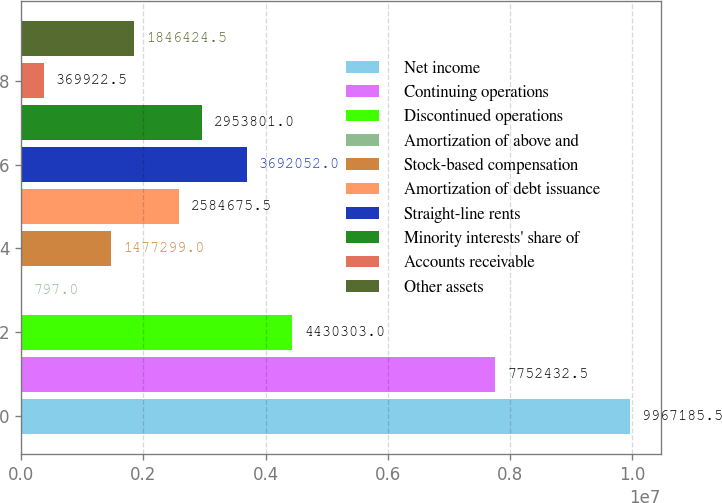Convert chart to OTSL. <chart><loc_0><loc_0><loc_500><loc_500><bar_chart><fcel>Net income<fcel>Continuing operations<fcel>Discontinued operations<fcel>Amortization of above and<fcel>Stock-based compensation<fcel>Amortization of debt issuance<fcel>Straight-line rents<fcel>Minority interests' share of<fcel>Accounts receivable<fcel>Other assets<nl><fcel>9.96719e+06<fcel>7.75243e+06<fcel>4.4303e+06<fcel>797<fcel>1.4773e+06<fcel>2.58468e+06<fcel>3.69205e+06<fcel>2.9538e+06<fcel>369922<fcel>1.84642e+06<nl></chart> 